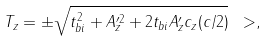Convert formula to latex. <formula><loc_0><loc_0><loc_500><loc_500>T _ { z } = \pm \sqrt { t _ { b i } ^ { 2 } + A _ { z } ^ { \prime 2 } + 2 t _ { b i } A ^ { \prime } _ { z } c _ { z } ( c / 2 ) } \ > ,</formula> 